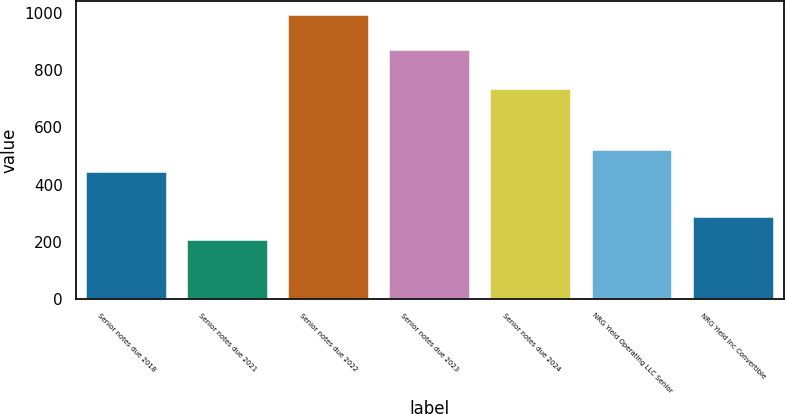<chart> <loc_0><loc_0><loc_500><loc_500><bar_chart><fcel>Senior notes due 2018<fcel>Senior notes due 2021<fcel>Senior notes due 2022<fcel>Senior notes due 2023<fcel>Senior notes due 2024<fcel>NRG Yield Operating LLC Senior<fcel>NRG Yield Inc Convertible<nl><fcel>442.5<fcel>207<fcel>992<fcel>869<fcel>733<fcel>521<fcel>285.5<nl></chart> 